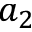<formula> <loc_0><loc_0><loc_500><loc_500>a _ { 2 }</formula> 